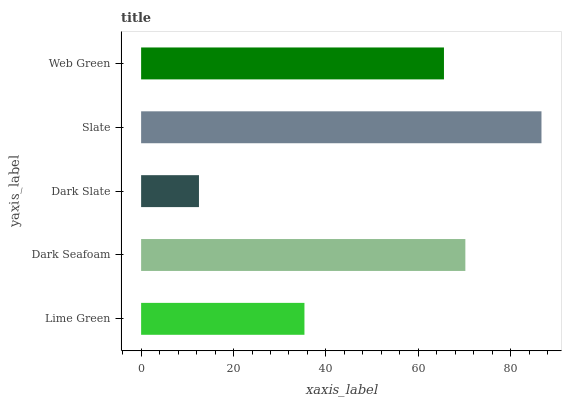Is Dark Slate the minimum?
Answer yes or no. Yes. Is Slate the maximum?
Answer yes or no. Yes. Is Dark Seafoam the minimum?
Answer yes or no. No. Is Dark Seafoam the maximum?
Answer yes or no. No. Is Dark Seafoam greater than Lime Green?
Answer yes or no. Yes. Is Lime Green less than Dark Seafoam?
Answer yes or no. Yes. Is Lime Green greater than Dark Seafoam?
Answer yes or no. No. Is Dark Seafoam less than Lime Green?
Answer yes or no. No. Is Web Green the high median?
Answer yes or no. Yes. Is Web Green the low median?
Answer yes or no. Yes. Is Dark Seafoam the high median?
Answer yes or no. No. Is Dark Slate the low median?
Answer yes or no. No. 